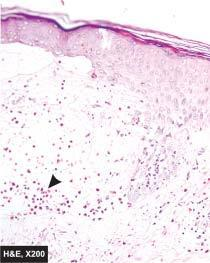does the skin show non-acantholytic subepidermal bulla containing microabscess of eosinophils?
Answer the question using a single word or phrase. Yes 